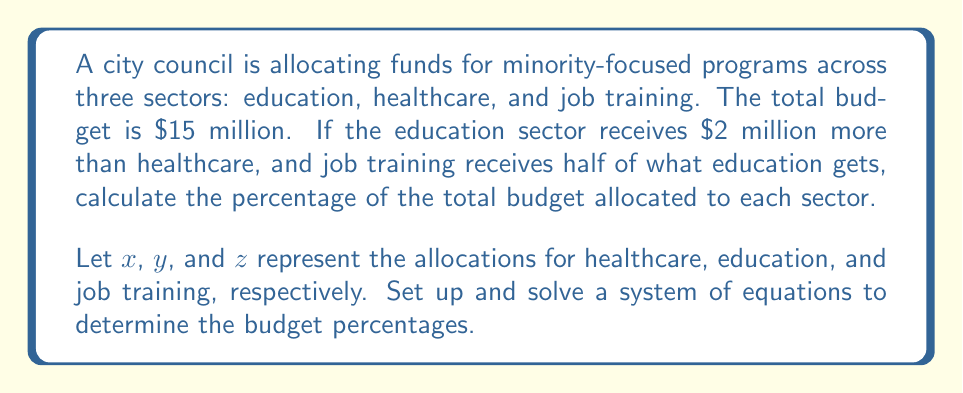Help me with this question. Step 1: Set up the system of equations based on the given information.
$$\begin{cases}
x + y + z = 15 \text{ (total budget)} \\
y = x + 2 \text{ (education gets $2 million more than healthcare)} \\
z = \frac{1}{2}y \text{ (job training gets half of education)}
\end{cases}$$

Step 2: Substitute the expressions for $y$ and $z$ into the first equation.
$$x + (x + 2) + \frac{1}{2}(x + 2) = 15$$

Step 3: Simplify the equation.
$$x + x + 2 + \frac{1}{2}x + 1 = 15$$
$$2.5x + 3 = 15$$

Step 4: Solve for $x$ (healthcare).
$$2.5x = 12$$
$$x = 4.8$$

Step 5: Calculate $y$ (education) and $z$ (job training).
$$y = x + 2 = 4.8 + 2 = 6.8$$
$$z = \frac{1}{2}y = \frac{1}{2}(6.8) = 3.4$$

Step 6: Calculate the percentages for each sector.
Healthcare: $\frac{4.8}{15} \times 100\% = 32\%$
Education: $\frac{6.8}{15} \times 100\% = 45.33\%$
Job Training: $\frac{3.4}{15} \times 100\% = 22.67\%$
Answer: Healthcare: 32%, Education: 45.33%, Job Training: 22.67% 